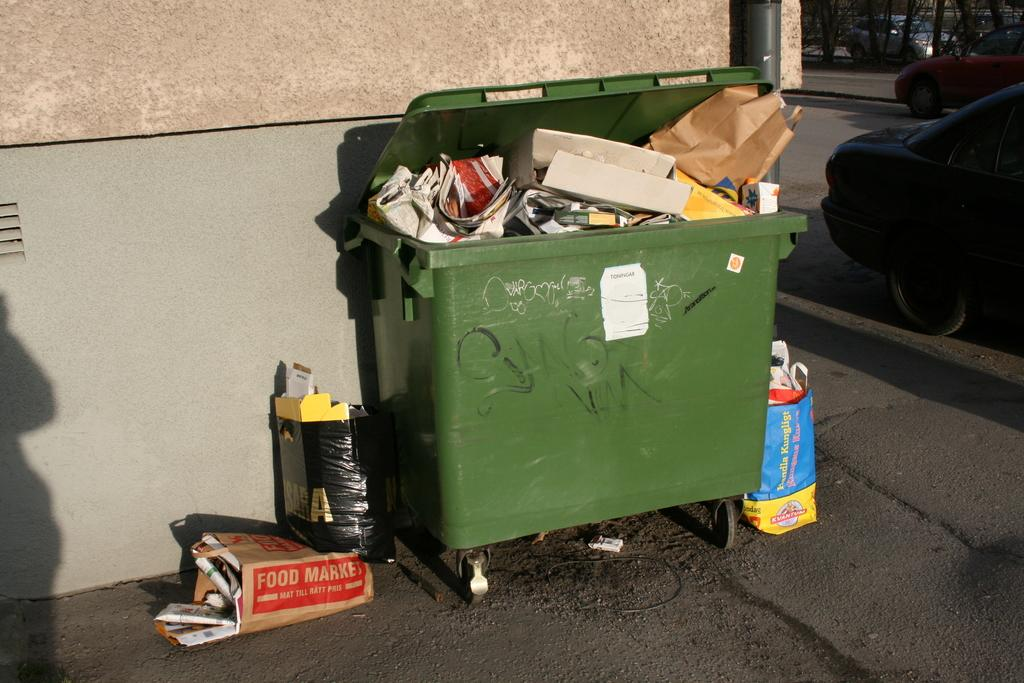<image>
Present a compact description of the photo's key features. A brown bag that says "food market" on the side sits next to a dumpster. 